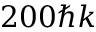<formula> <loc_0><loc_0><loc_500><loc_500>2 0 0 \hbar { k }</formula> 